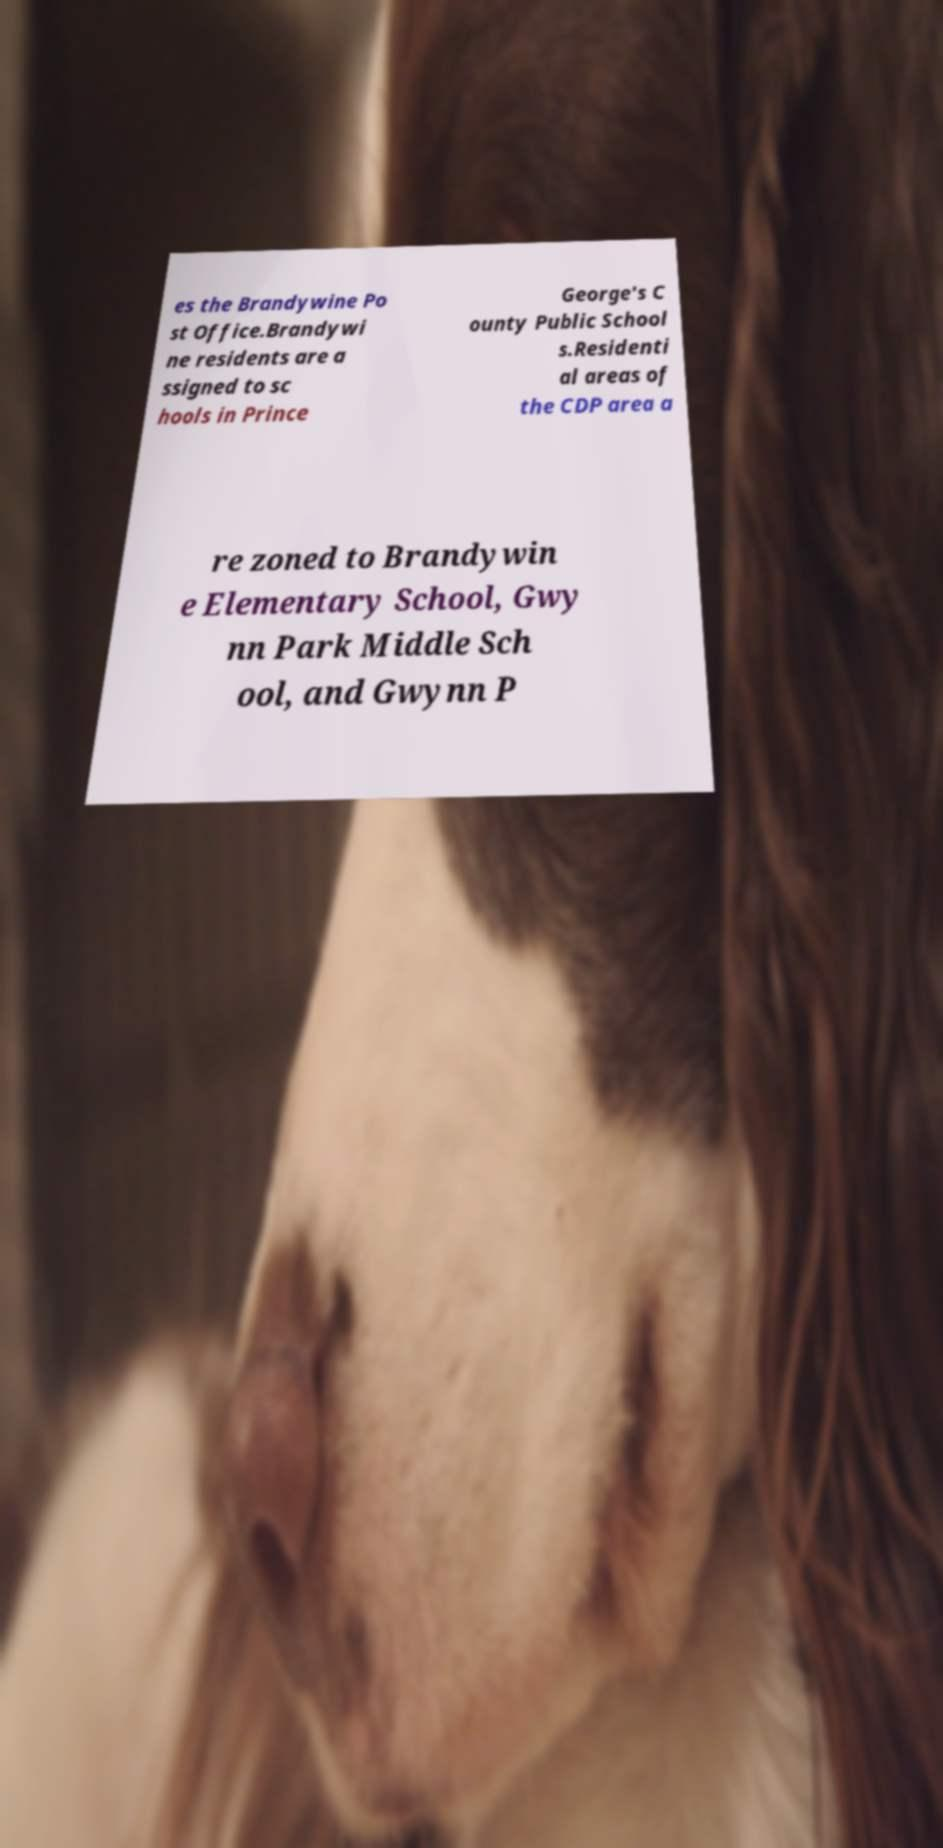Could you extract and type out the text from this image? es the Brandywine Po st Office.Brandywi ne residents are a ssigned to sc hools in Prince George's C ounty Public School s.Residenti al areas of the CDP area a re zoned to Brandywin e Elementary School, Gwy nn Park Middle Sch ool, and Gwynn P 